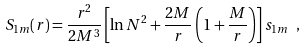<formula> <loc_0><loc_0><loc_500><loc_500>S _ { 1 m } ( r ) = \frac { r ^ { 2 } } { 2 M ^ { 3 } } \left [ \ln N ^ { 2 } + \frac { 2 M } { r } \left ( 1 + \frac { M } { r } \right ) \right ] s _ { 1 m } \ ,</formula> 